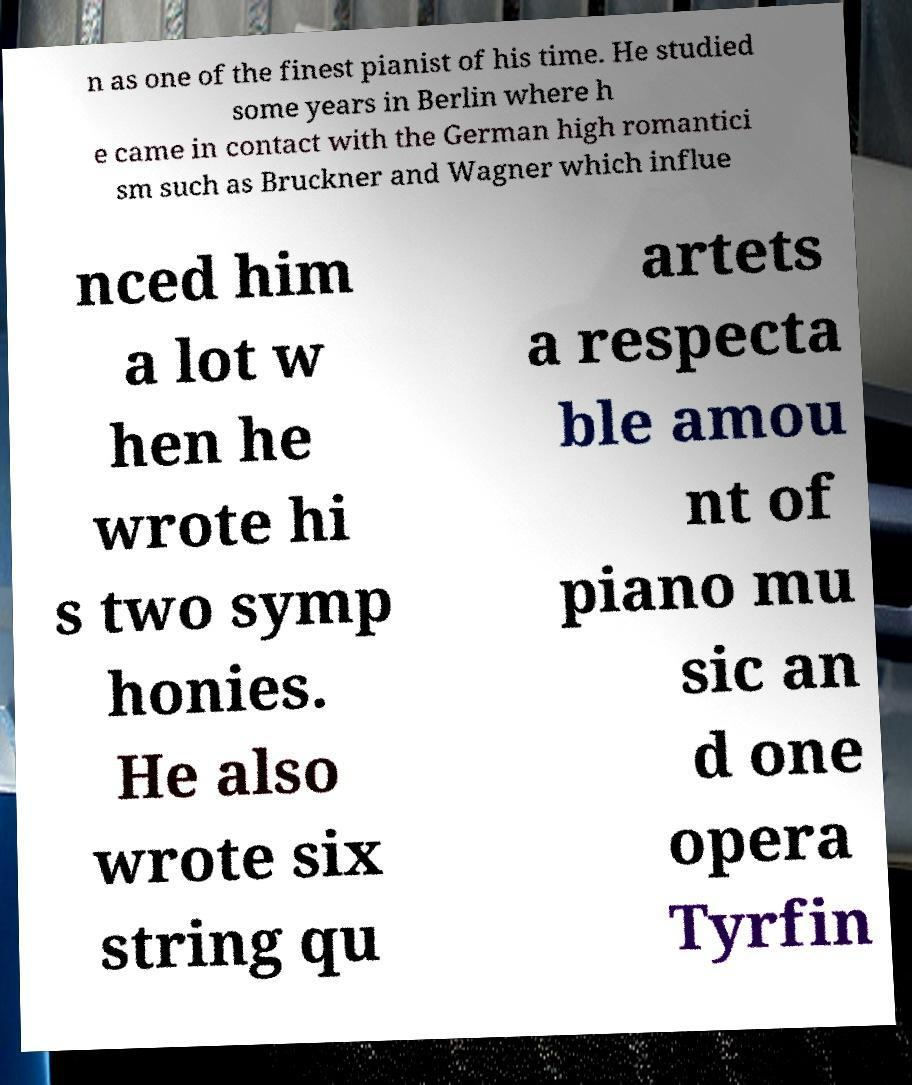Can you accurately transcribe the text from the provided image for me? n as one of the finest pianist of his time. He studied some years in Berlin where h e came in contact with the German high romantici sm such as Bruckner and Wagner which influe nced him a lot w hen he wrote hi s two symp honies. He also wrote six string qu artets a respecta ble amou nt of piano mu sic an d one opera Tyrfin 